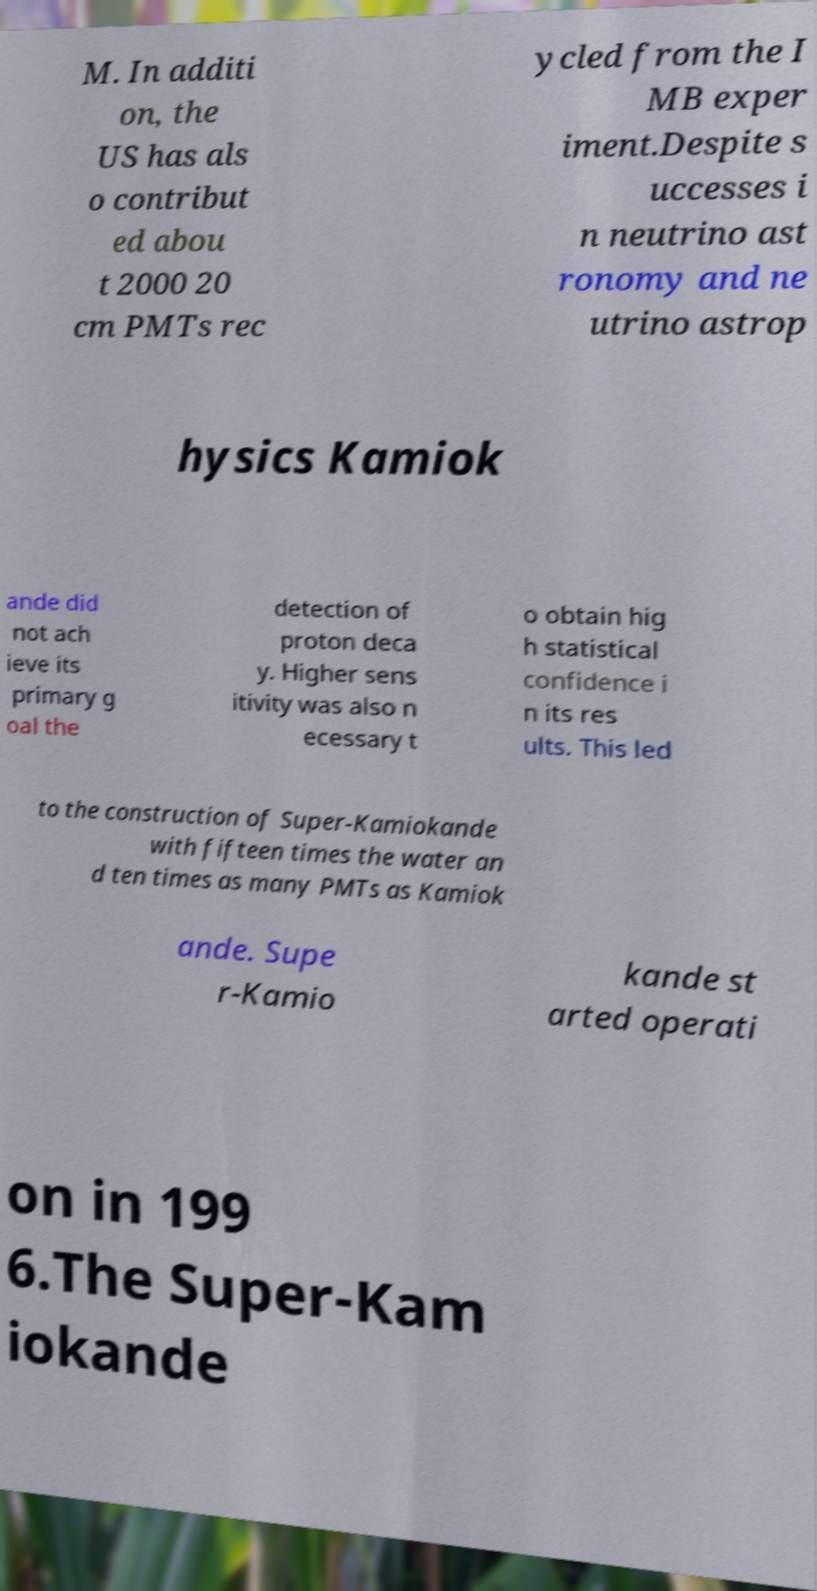Please read and relay the text visible in this image. What does it say? M. In additi on, the US has als o contribut ed abou t 2000 20 cm PMTs rec ycled from the I MB exper iment.Despite s uccesses i n neutrino ast ronomy and ne utrino astrop hysics Kamiok ande did not ach ieve its primary g oal the detection of proton deca y. Higher sens itivity was also n ecessary t o obtain hig h statistical confidence i n its res ults. This led to the construction of Super-Kamiokande with fifteen times the water an d ten times as many PMTs as Kamiok ande. Supe r-Kamio kande st arted operati on in 199 6.The Super-Kam iokande 